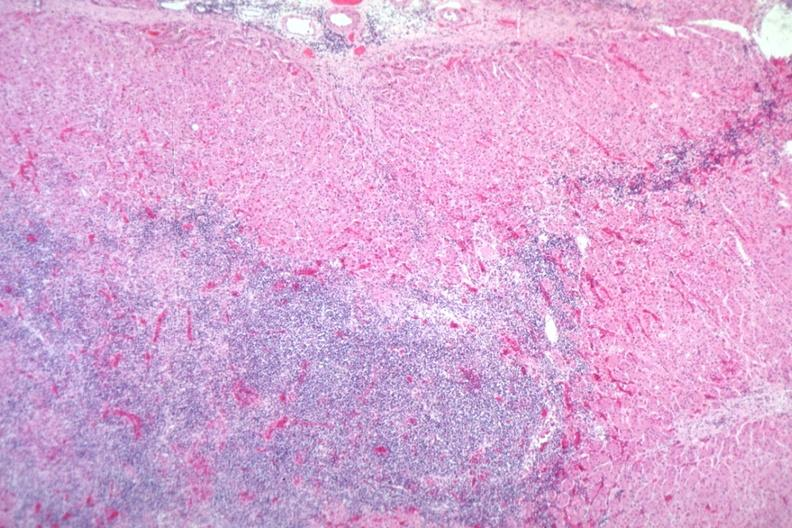what is present?
Answer the question using a single word or phrase. Adrenal 